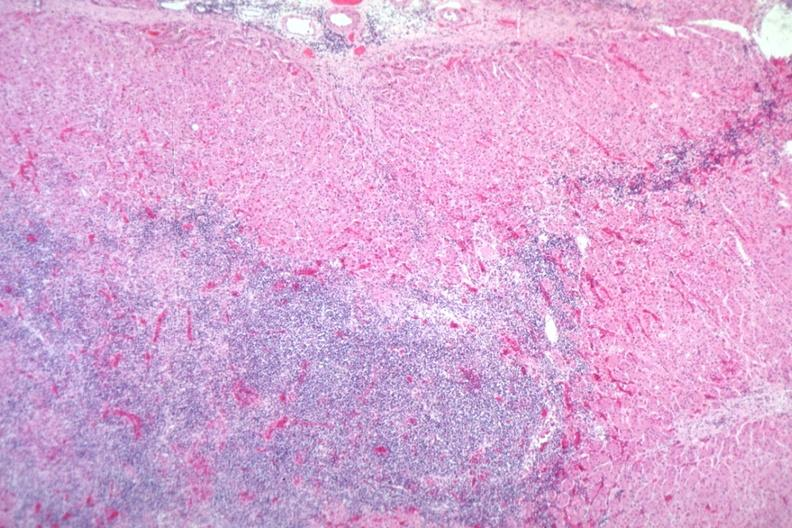what is present?
Answer the question using a single word or phrase. Adrenal 